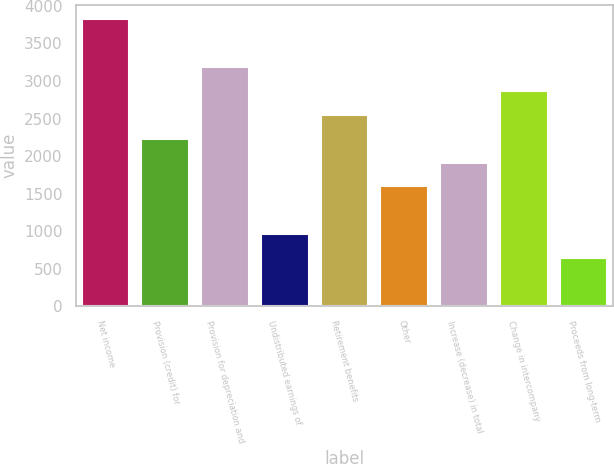<chart> <loc_0><loc_0><loc_500><loc_500><bar_chart><fcel>Net income<fcel>Provision (credit) for<fcel>Provision for depreciation and<fcel>Undistributed earnings of<fcel>Retirement benefits<fcel>Other<fcel>Increase (decrease) in total<fcel>Change in intercompany<fcel>Proceeds from long-term<nl><fcel>3824.1<fcel>2232.6<fcel>3187.5<fcel>959.4<fcel>2550.9<fcel>1596<fcel>1914.3<fcel>2869.2<fcel>641.1<nl></chart> 